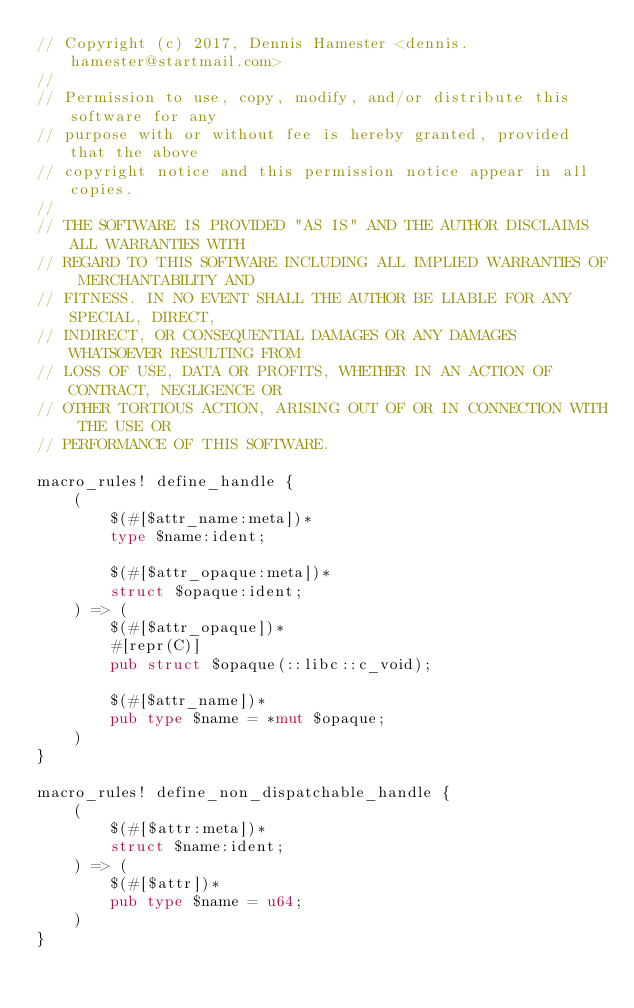<code> <loc_0><loc_0><loc_500><loc_500><_Rust_>// Copyright (c) 2017, Dennis Hamester <dennis.hamester@startmail.com>
//
// Permission to use, copy, modify, and/or distribute this software for any
// purpose with or without fee is hereby granted, provided that the above
// copyright notice and this permission notice appear in all copies.
//
// THE SOFTWARE IS PROVIDED "AS IS" AND THE AUTHOR DISCLAIMS ALL WARRANTIES WITH
// REGARD TO THIS SOFTWARE INCLUDING ALL IMPLIED WARRANTIES OF MERCHANTABILITY AND
// FITNESS. IN NO EVENT SHALL THE AUTHOR BE LIABLE FOR ANY SPECIAL, DIRECT,
// INDIRECT, OR CONSEQUENTIAL DAMAGES OR ANY DAMAGES WHATSOEVER RESULTING FROM
// LOSS OF USE, DATA OR PROFITS, WHETHER IN AN ACTION OF CONTRACT, NEGLIGENCE OR
// OTHER TORTIOUS ACTION, ARISING OUT OF OR IN CONNECTION WITH THE USE OR
// PERFORMANCE OF THIS SOFTWARE.

macro_rules! define_handle {
    (
        $(#[$attr_name:meta])*
        type $name:ident;

        $(#[$attr_opaque:meta])*
        struct $opaque:ident;
    ) => (
        $(#[$attr_opaque])*
        #[repr(C)]
        pub struct $opaque(::libc::c_void);

        $(#[$attr_name])*
        pub type $name = *mut $opaque;
    )
}

macro_rules! define_non_dispatchable_handle {
    (
        $(#[$attr:meta])*
        struct $name:ident;
    ) => (
        $(#[$attr])*
        pub type $name = u64;
    )
}
</code> 